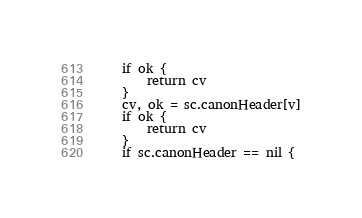Convert code to text. <code><loc_0><loc_0><loc_500><loc_500><_Go_>	if ok {
		return cv
	}
	cv, ok = sc.canonHeader[v]
	if ok {
		return cv
	}
	if sc.canonHeader == nil {</code> 